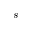Convert formula to latex. <formula><loc_0><loc_0><loc_500><loc_500>s</formula> 